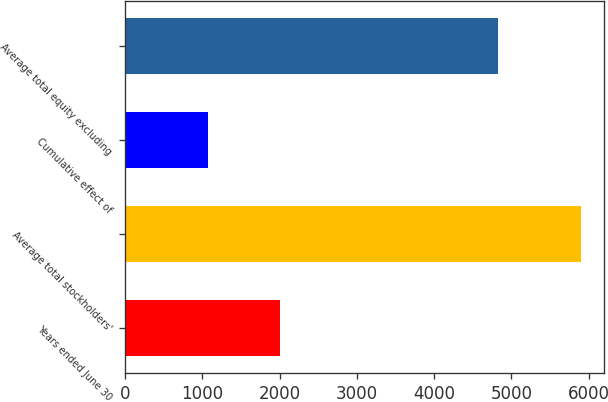Convert chart. <chart><loc_0><loc_0><loc_500><loc_500><bar_chart><fcel>Years ended June 30<fcel>Average total stockholders'<fcel>Cumulative effect of<fcel>Average total equity excluding<nl><fcel>2006<fcel>5897.7<fcel>1069.1<fcel>4828.6<nl></chart> 